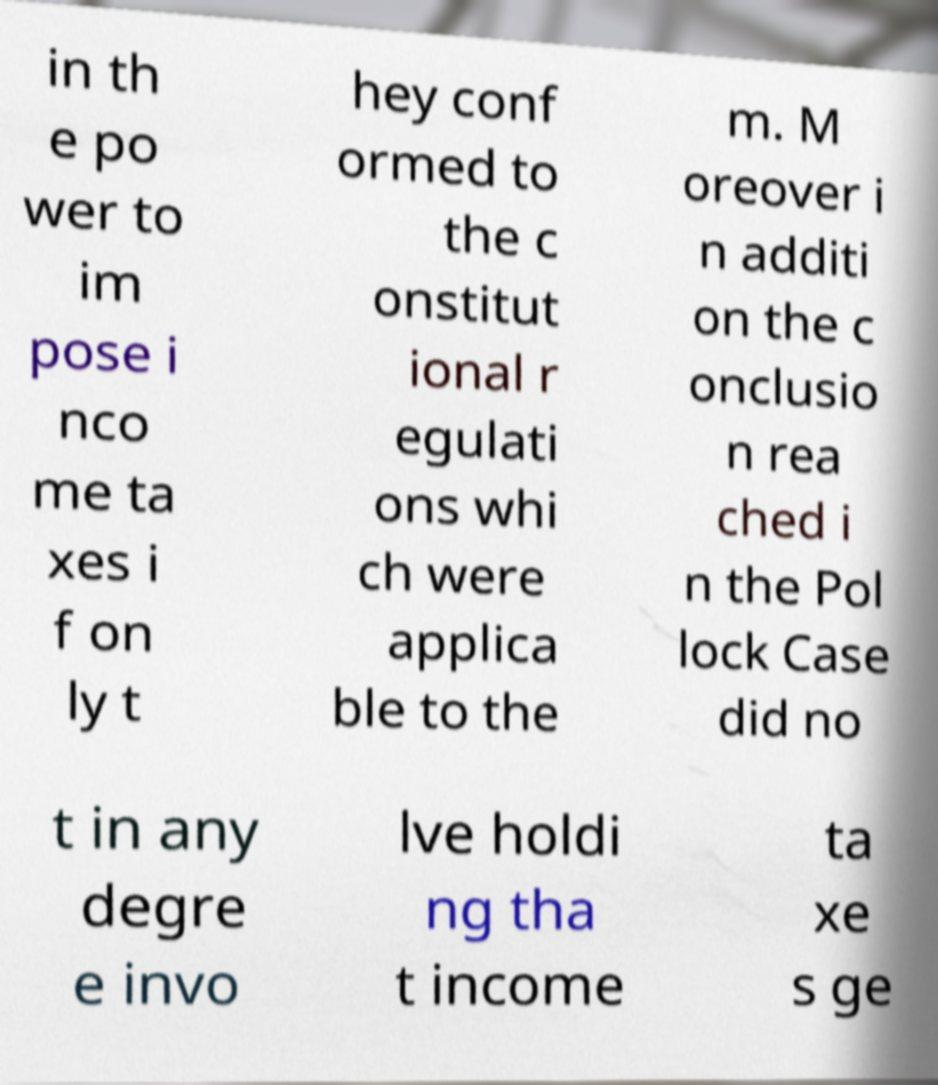Can you accurately transcribe the text from the provided image for me? in th e po wer to im pose i nco me ta xes i f on ly t hey conf ormed to the c onstitut ional r egulati ons whi ch were applica ble to the m. M oreover i n additi on the c onclusio n rea ched i n the Pol lock Case did no t in any degre e invo lve holdi ng tha t income ta xe s ge 